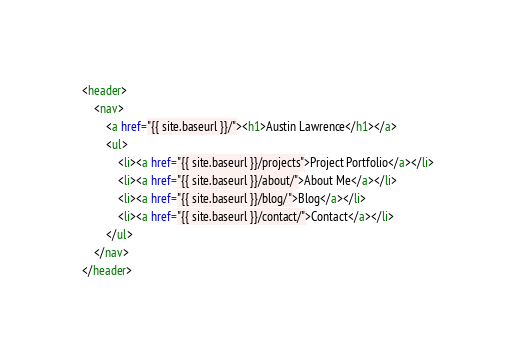Convert code to text. <code><loc_0><loc_0><loc_500><loc_500><_HTML_><header>
    <nav>
    	<a href="{{ site.baseurl }}/"><h1>Austin Lawrence</h1></a>
    	<ul>
    		<li><a href="{{ site.baseurl }}/projects">Project Portfolio</a></li>
    		<li><a href="{{ site.baseurl }}/about/">About Me</a></li>
    		<li><a href="{{ site.baseurl }}/blog/">Blog</a></li>
    		<li><a href="{{ site.baseurl }}/contact/">Contact</a></li>
    	</ul>
    </nav>
</header>
</code> 